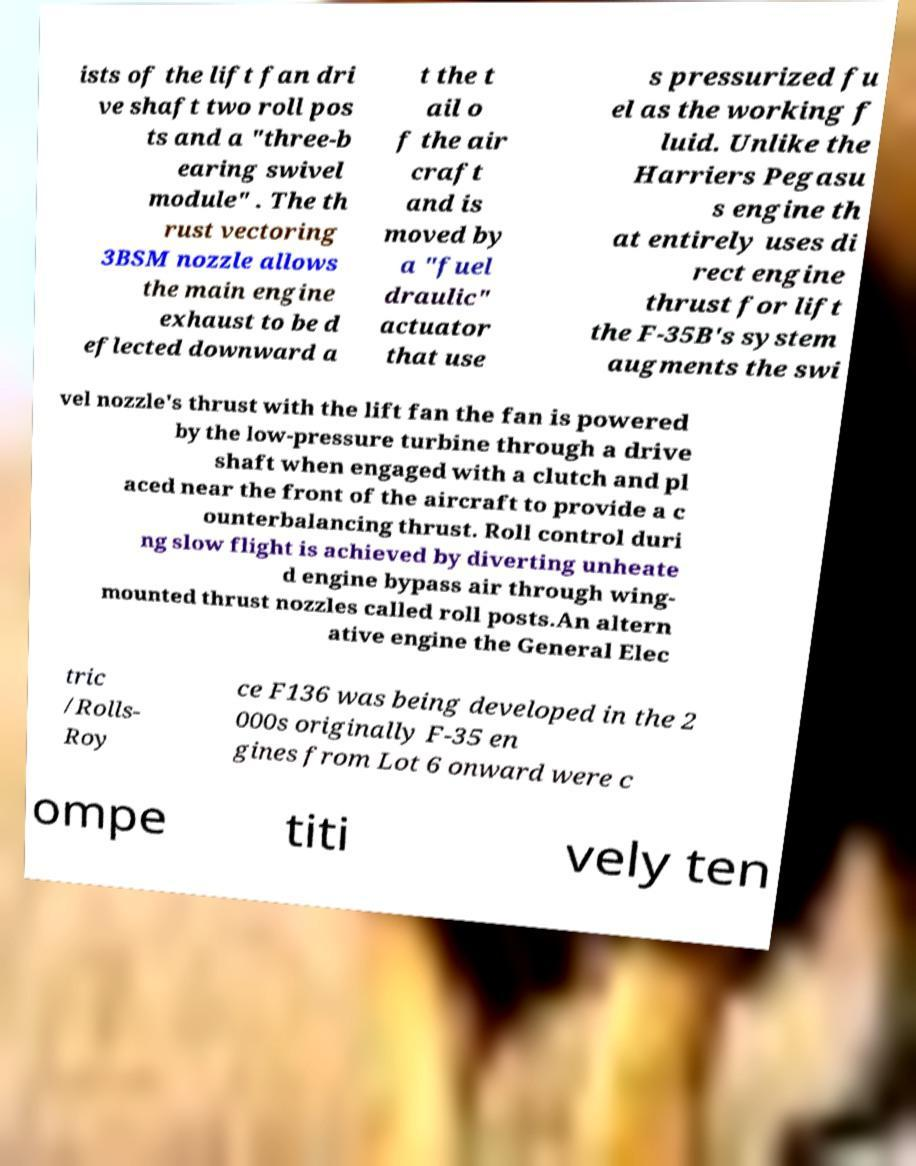What messages or text are displayed in this image? I need them in a readable, typed format. ists of the lift fan dri ve shaft two roll pos ts and a "three-b earing swivel module" . The th rust vectoring 3BSM nozzle allows the main engine exhaust to be d eflected downward a t the t ail o f the air craft and is moved by a "fuel draulic" actuator that use s pressurized fu el as the working f luid. Unlike the Harriers Pegasu s engine th at entirely uses di rect engine thrust for lift the F-35B's system augments the swi vel nozzle's thrust with the lift fan the fan is powered by the low-pressure turbine through a drive shaft when engaged with a clutch and pl aced near the front of the aircraft to provide a c ounterbalancing thrust. Roll control duri ng slow flight is achieved by diverting unheate d engine bypass air through wing- mounted thrust nozzles called roll posts.An altern ative engine the General Elec tric /Rolls- Roy ce F136 was being developed in the 2 000s originally F-35 en gines from Lot 6 onward were c ompe titi vely ten 